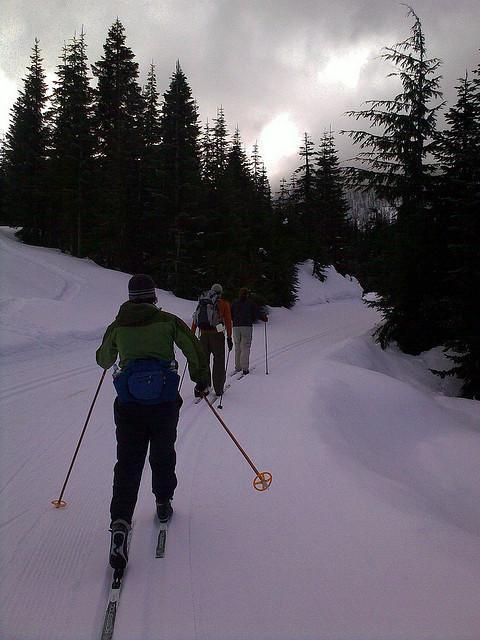How many people are there?
Give a very brief answer. 2. How many train tracks are there?
Give a very brief answer. 0. 